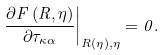<formula> <loc_0><loc_0><loc_500><loc_500>\left . \frac { \partial F \left ( R , \eta \right ) } { \partial \tau _ { \kappa \alpha } } \right | _ { R ( \eta ) , \eta } = 0 .</formula> 